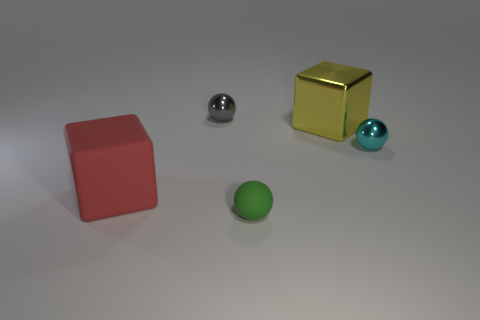There is another small metallic object that is the same shape as the cyan object; what is its color?
Give a very brief answer. Gray. There is a cube that is made of the same material as the gray ball; what color is it?
Offer a terse response. Yellow. How many yellow rubber cylinders have the same size as the red matte thing?
Keep it short and to the point. 0. What material is the big red thing?
Your answer should be compact. Rubber. Is the number of small cyan things greater than the number of cyan blocks?
Provide a succinct answer. Yes. Does the green matte thing have the same shape as the small cyan object?
Offer a terse response. Yes. Are there any other things that have the same shape as the small rubber thing?
Give a very brief answer. Yes. Does the block that is behind the matte block have the same color as the tiny metal thing right of the green rubber object?
Your answer should be very brief. No. Is the number of spheres behind the big shiny thing less than the number of matte cubes that are right of the rubber block?
Provide a short and direct response. No. There is a small metal object that is in front of the tiny gray object; what is its shape?
Keep it short and to the point. Sphere. 